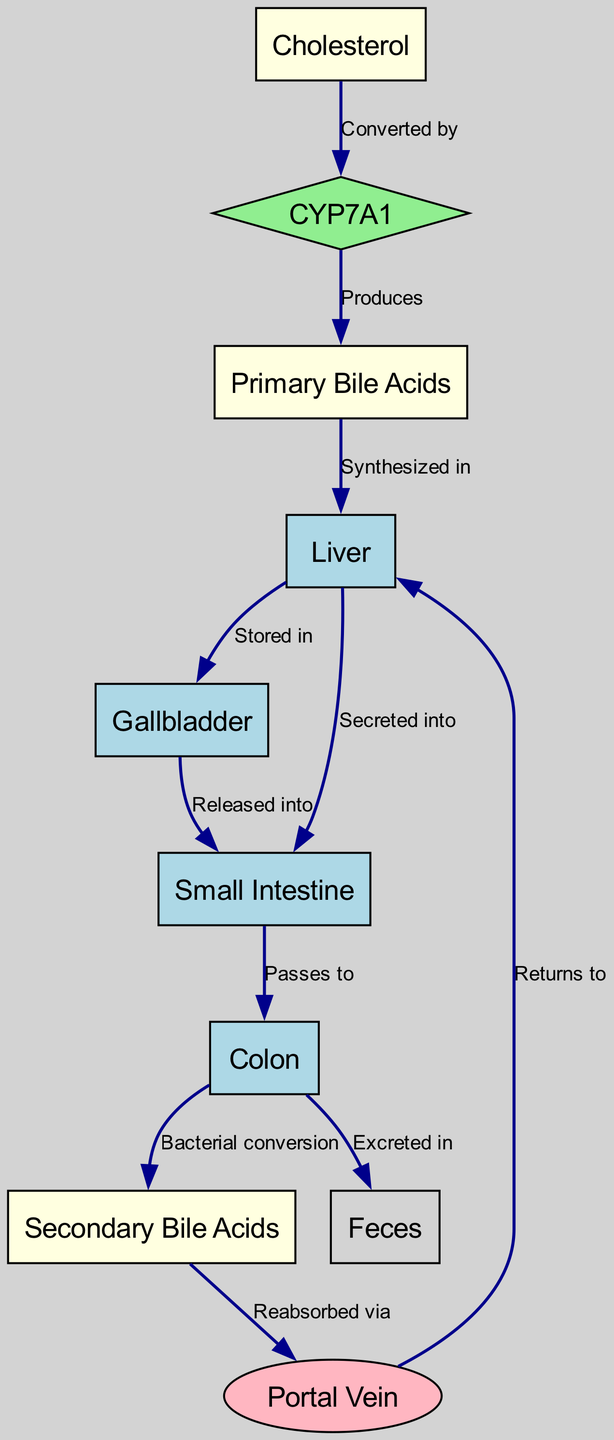What is the first step in bile acid synthesis? The diagram indicates that the first step in bile acid synthesis involves the conversion of cholesterol by the enzyme CYP7A1. This is represented by the edge from "Cholesterol" to "CYP7A1" labeled "Converted by."
Answer: CYP7A1 How many types of bile acids are mentioned in the diagram? The diagram lists two types of bile acids: "Primary Bile Acids" and "Secondary Bile Acids." These can be counted as they are displayed as separate nodes.
Answer: Two What is produced by CYP7A1? Looking at the edge labeled "Produces," it shows that CYP7A1 is directly linked to "Primary Bile Acids," indicating that it is what CYP7A1 produces.
Answer: Primary Bile Acids Where are bile acids stored in the body? The flow from "Liver" to "Gallbladder" indicates that bile acids are stored in the gallbladder, as denoted by the edge labeled "Stored in."
Answer: Gallbladder What happens to bile acids after passing through the colon? The diagram shows two outcomes from the "Colon": one leads to "Secondary Bile Acids" through bacterial conversion, and the other leads to "Feces" labeled "Excreted in." This indicates that bile acids can either be converted or excreted.
Answer: Excreted in What pathway do secondary bile acids take after reabsorption? The edge from "Secondary Bile Acids" to "Portal Vein" indicates that secondary bile acids are reabsorbed via the portal vein. This establishes the pathway after reabsorption.
Answer: Portal Vein Which nodes are considered organs in this diagram? The nodes that represent organs are "Liver," "Gallbladder," "Small Intestine," and "Colon." They can be identified by recognizing them as physiological structures involved in the process.
Answer: Liver, Gallbladder, Small Intestine, Colon What is the relationship between the colon and feces in this diagram? There is a direct edge connecting "Colon" to "Feces" with the label "Excreted in," indicating that the colon is responsible for the excretion of substances into feces.
Answer: Excreted in What is the function of the portal vein in the enterohepatic circulation? The diagram shows that the portal vein receives secondary bile acids that are reabsorbed from the colon, indicating that its function is to return these bile acids to the liver.
Answer: Returns to 